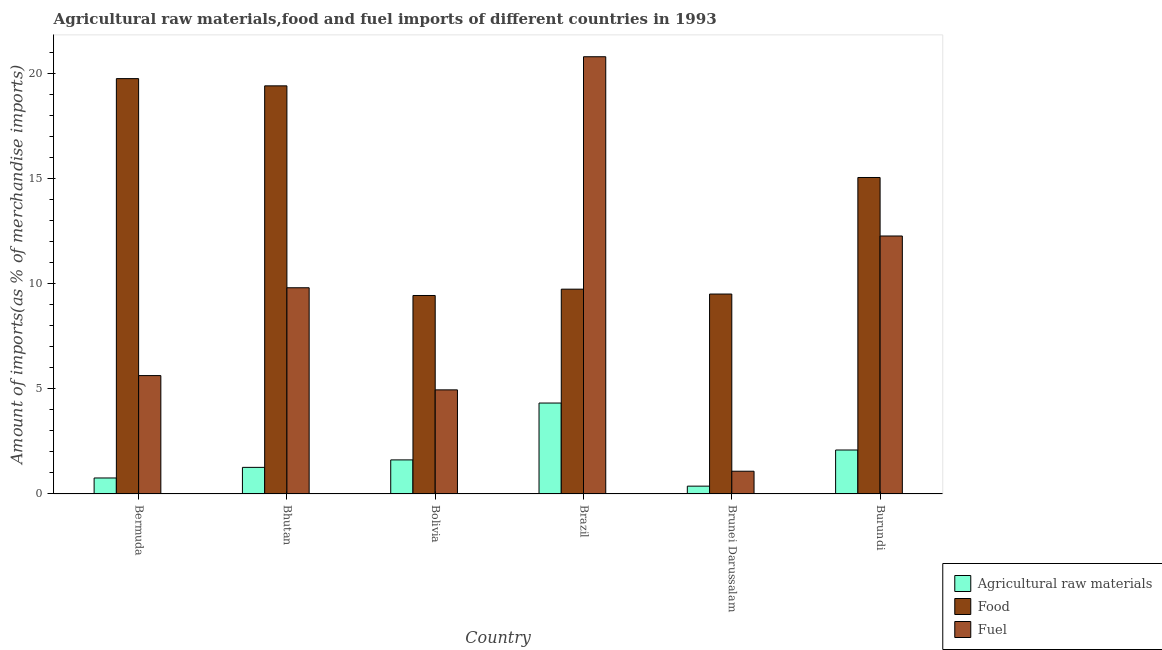How many different coloured bars are there?
Ensure brevity in your answer.  3. Are the number of bars per tick equal to the number of legend labels?
Ensure brevity in your answer.  Yes. What is the label of the 6th group of bars from the left?
Provide a short and direct response. Burundi. In how many cases, is the number of bars for a given country not equal to the number of legend labels?
Keep it short and to the point. 0. What is the percentage of food imports in Burundi?
Ensure brevity in your answer.  15.04. Across all countries, what is the maximum percentage of food imports?
Your answer should be compact. 19.74. Across all countries, what is the minimum percentage of fuel imports?
Your answer should be very brief. 1.08. In which country was the percentage of food imports maximum?
Offer a very short reply. Bermuda. In which country was the percentage of raw materials imports minimum?
Your answer should be compact. Brunei Darussalam. What is the total percentage of raw materials imports in the graph?
Offer a terse response. 10.42. What is the difference between the percentage of food imports in Bhutan and that in Brunei Darussalam?
Your answer should be compact. 9.89. What is the difference between the percentage of food imports in Burundi and the percentage of fuel imports in Brazil?
Provide a succinct answer. -5.74. What is the average percentage of food imports per country?
Give a very brief answer. 13.81. What is the difference between the percentage of fuel imports and percentage of food imports in Bermuda?
Make the answer very short. -14.11. In how many countries, is the percentage of food imports greater than 16 %?
Offer a very short reply. 2. What is the ratio of the percentage of food imports in Bolivia to that in Brunei Darussalam?
Keep it short and to the point. 0.99. Is the difference between the percentage of raw materials imports in Bermuda and Brunei Darussalam greater than the difference between the percentage of fuel imports in Bermuda and Brunei Darussalam?
Give a very brief answer. No. What is the difference between the highest and the second highest percentage of fuel imports?
Offer a very short reply. 8.52. What is the difference between the highest and the lowest percentage of food imports?
Your response must be concise. 10.31. In how many countries, is the percentage of fuel imports greater than the average percentage of fuel imports taken over all countries?
Your answer should be compact. 3. Is the sum of the percentage of food imports in Bhutan and Brunei Darussalam greater than the maximum percentage of raw materials imports across all countries?
Offer a terse response. Yes. What does the 2nd bar from the left in Bhutan represents?
Your answer should be compact. Food. What does the 2nd bar from the right in Bermuda represents?
Your answer should be compact. Food. Are all the bars in the graph horizontal?
Offer a very short reply. No. What is the difference between two consecutive major ticks on the Y-axis?
Your response must be concise. 5. Are the values on the major ticks of Y-axis written in scientific E-notation?
Provide a short and direct response. No. Does the graph contain grids?
Your response must be concise. No. How many legend labels are there?
Keep it short and to the point. 3. What is the title of the graph?
Offer a terse response. Agricultural raw materials,food and fuel imports of different countries in 1993. What is the label or title of the Y-axis?
Provide a short and direct response. Amount of imports(as % of merchandise imports). What is the Amount of imports(as % of merchandise imports) of Agricultural raw materials in Bermuda?
Keep it short and to the point. 0.76. What is the Amount of imports(as % of merchandise imports) of Food in Bermuda?
Your answer should be very brief. 19.74. What is the Amount of imports(as % of merchandise imports) in Fuel in Bermuda?
Make the answer very short. 5.63. What is the Amount of imports(as % of merchandise imports) in Agricultural raw materials in Bhutan?
Your answer should be very brief. 1.26. What is the Amount of imports(as % of merchandise imports) of Food in Bhutan?
Ensure brevity in your answer.  19.39. What is the Amount of imports(as % of merchandise imports) in Fuel in Bhutan?
Offer a very short reply. 9.8. What is the Amount of imports(as % of merchandise imports) in Agricultural raw materials in Bolivia?
Provide a succinct answer. 1.62. What is the Amount of imports(as % of merchandise imports) of Food in Bolivia?
Offer a terse response. 9.43. What is the Amount of imports(as % of merchandise imports) of Fuel in Bolivia?
Provide a short and direct response. 4.95. What is the Amount of imports(as % of merchandise imports) in Agricultural raw materials in Brazil?
Offer a terse response. 4.32. What is the Amount of imports(as % of merchandise imports) of Food in Brazil?
Provide a succinct answer. 9.73. What is the Amount of imports(as % of merchandise imports) in Fuel in Brazil?
Your response must be concise. 20.78. What is the Amount of imports(as % of merchandise imports) in Agricultural raw materials in Brunei Darussalam?
Your answer should be compact. 0.37. What is the Amount of imports(as % of merchandise imports) in Food in Brunei Darussalam?
Ensure brevity in your answer.  9.5. What is the Amount of imports(as % of merchandise imports) in Fuel in Brunei Darussalam?
Offer a terse response. 1.08. What is the Amount of imports(as % of merchandise imports) in Agricultural raw materials in Burundi?
Offer a terse response. 2.09. What is the Amount of imports(as % of merchandise imports) of Food in Burundi?
Keep it short and to the point. 15.04. What is the Amount of imports(as % of merchandise imports) in Fuel in Burundi?
Make the answer very short. 12.26. Across all countries, what is the maximum Amount of imports(as % of merchandise imports) in Agricultural raw materials?
Your answer should be very brief. 4.32. Across all countries, what is the maximum Amount of imports(as % of merchandise imports) in Food?
Provide a succinct answer. 19.74. Across all countries, what is the maximum Amount of imports(as % of merchandise imports) of Fuel?
Your response must be concise. 20.78. Across all countries, what is the minimum Amount of imports(as % of merchandise imports) in Agricultural raw materials?
Your answer should be compact. 0.37. Across all countries, what is the minimum Amount of imports(as % of merchandise imports) of Food?
Your answer should be very brief. 9.43. Across all countries, what is the minimum Amount of imports(as % of merchandise imports) of Fuel?
Ensure brevity in your answer.  1.08. What is the total Amount of imports(as % of merchandise imports) of Agricultural raw materials in the graph?
Provide a short and direct response. 10.42. What is the total Amount of imports(as % of merchandise imports) in Food in the graph?
Ensure brevity in your answer.  82.83. What is the total Amount of imports(as % of merchandise imports) in Fuel in the graph?
Offer a very short reply. 54.49. What is the difference between the Amount of imports(as % of merchandise imports) of Agricultural raw materials in Bermuda and that in Bhutan?
Your response must be concise. -0.5. What is the difference between the Amount of imports(as % of merchandise imports) of Food in Bermuda and that in Bhutan?
Provide a succinct answer. 0.34. What is the difference between the Amount of imports(as % of merchandise imports) in Fuel in Bermuda and that in Bhutan?
Provide a short and direct response. -4.17. What is the difference between the Amount of imports(as % of merchandise imports) in Agricultural raw materials in Bermuda and that in Bolivia?
Keep it short and to the point. -0.86. What is the difference between the Amount of imports(as % of merchandise imports) in Food in Bermuda and that in Bolivia?
Your answer should be very brief. 10.31. What is the difference between the Amount of imports(as % of merchandise imports) of Fuel in Bermuda and that in Bolivia?
Make the answer very short. 0.68. What is the difference between the Amount of imports(as % of merchandise imports) in Agricultural raw materials in Bermuda and that in Brazil?
Offer a terse response. -3.56. What is the difference between the Amount of imports(as % of merchandise imports) in Food in Bermuda and that in Brazil?
Offer a terse response. 10.01. What is the difference between the Amount of imports(as % of merchandise imports) of Fuel in Bermuda and that in Brazil?
Your answer should be very brief. -15.15. What is the difference between the Amount of imports(as % of merchandise imports) in Agricultural raw materials in Bermuda and that in Brunei Darussalam?
Your response must be concise. 0.39. What is the difference between the Amount of imports(as % of merchandise imports) in Food in Bermuda and that in Brunei Darussalam?
Provide a short and direct response. 10.24. What is the difference between the Amount of imports(as % of merchandise imports) in Fuel in Bermuda and that in Brunei Darussalam?
Your answer should be compact. 4.55. What is the difference between the Amount of imports(as % of merchandise imports) of Agricultural raw materials in Bermuda and that in Burundi?
Offer a very short reply. -1.33. What is the difference between the Amount of imports(as % of merchandise imports) of Food in Bermuda and that in Burundi?
Your response must be concise. 4.7. What is the difference between the Amount of imports(as % of merchandise imports) in Fuel in Bermuda and that in Burundi?
Your response must be concise. -6.63. What is the difference between the Amount of imports(as % of merchandise imports) of Agricultural raw materials in Bhutan and that in Bolivia?
Ensure brevity in your answer.  -0.35. What is the difference between the Amount of imports(as % of merchandise imports) in Food in Bhutan and that in Bolivia?
Offer a terse response. 9.96. What is the difference between the Amount of imports(as % of merchandise imports) in Fuel in Bhutan and that in Bolivia?
Your response must be concise. 4.85. What is the difference between the Amount of imports(as % of merchandise imports) of Agricultural raw materials in Bhutan and that in Brazil?
Your answer should be compact. -3.06. What is the difference between the Amount of imports(as % of merchandise imports) in Food in Bhutan and that in Brazil?
Make the answer very short. 9.66. What is the difference between the Amount of imports(as % of merchandise imports) in Fuel in Bhutan and that in Brazil?
Make the answer very short. -10.98. What is the difference between the Amount of imports(as % of merchandise imports) in Agricultural raw materials in Bhutan and that in Brunei Darussalam?
Offer a terse response. 0.89. What is the difference between the Amount of imports(as % of merchandise imports) in Food in Bhutan and that in Brunei Darussalam?
Offer a very short reply. 9.89. What is the difference between the Amount of imports(as % of merchandise imports) in Fuel in Bhutan and that in Brunei Darussalam?
Your answer should be very brief. 8.72. What is the difference between the Amount of imports(as % of merchandise imports) in Agricultural raw materials in Bhutan and that in Burundi?
Offer a very short reply. -0.82. What is the difference between the Amount of imports(as % of merchandise imports) in Food in Bhutan and that in Burundi?
Provide a short and direct response. 4.35. What is the difference between the Amount of imports(as % of merchandise imports) of Fuel in Bhutan and that in Burundi?
Give a very brief answer. -2.46. What is the difference between the Amount of imports(as % of merchandise imports) in Agricultural raw materials in Bolivia and that in Brazil?
Provide a succinct answer. -2.7. What is the difference between the Amount of imports(as % of merchandise imports) of Food in Bolivia and that in Brazil?
Offer a very short reply. -0.3. What is the difference between the Amount of imports(as % of merchandise imports) of Fuel in Bolivia and that in Brazil?
Make the answer very short. -15.83. What is the difference between the Amount of imports(as % of merchandise imports) of Agricultural raw materials in Bolivia and that in Brunei Darussalam?
Make the answer very short. 1.25. What is the difference between the Amount of imports(as % of merchandise imports) of Food in Bolivia and that in Brunei Darussalam?
Offer a terse response. -0.07. What is the difference between the Amount of imports(as % of merchandise imports) in Fuel in Bolivia and that in Brunei Darussalam?
Your answer should be very brief. 3.87. What is the difference between the Amount of imports(as % of merchandise imports) in Agricultural raw materials in Bolivia and that in Burundi?
Provide a short and direct response. -0.47. What is the difference between the Amount of imports(as % of merchandise imports) of Food in Bolivia and that in Burundi?
Keep it short and to the point. -5.61. What is the difference between the Amount of imports(as % of merchandise imports) of Fuel in Bolivia and that in Burundi?
Your answer should be compact. -7.31. What is the difference between the Amount of imports(as % of merchandise imports) in Agricultural raw materials in Brazil and that in Brunei Darussalam?
Ensure brevity in your answer.  3.95. What is the difference between the Amount of imports(as % of merchandise imports) in Food in Brazil and that in Brunei Darussalam?
Your answer should be compact. 0.23. What is the difference between the Amount of imports(as % of merchandise imports) in Fuel in Brazil and that in Brunei Darussalam?
Provide a short and direct response. 19.7. What is the difference between the Amount of imports(as % of merchandise imports) in Agricultural raw materials in Brazil and that in Burundi?
Offer a very short reply. 2.23. What is the difference between the Amount of imports(as % of merchandise imports) of Food in Brazil and that in Burundi?
Your answer should be compact. -5.31. What is the difference between the Amount of imports(as % of merchandise imports) of Fuel in Brazil and that in Burundi?
Ensure brevity in your answer.  8.52. What is the difference between the Amount of imports(as % of merchandise imports) in Agricultural raw materials in Brunei Darussalam and that in Burundi?
Make the answer very short. -1.72. What is the difference between the Amount of imports(as % of merchandise imports) in Food in Brunei Darussalam and that in Burundi?
Offer a terse response. -5.54. What is the difference between the Amount of imports(as % of merchandise imports) in Fuel in Brunei Darussalam and that in Burundi?
Give a very brief answer. -11.18. What is the difference between the Amount of imports(as % of merchandise imports) of Agricultural raw materials in Bermuda and the Amount of imports(as % of merchandise imports) of Food in Bhutan?
Give a very brief answer. -18.63. What is the difference between the Amount of imports(as % of merchandise imports) of Agricultural raw materials in Bermuda and the Amount of imports(as % of merchandise imports) of Fuel in Bhutan?
Offer a terse response. -9.04. What is the difference between the Amount of imports(as % of merchandise imports) of Food in Bermuda and the Amount of imports(as % of merchandise imports) of Fuel in Bhutan?
Your response must be concise. 9.94. What is the difference between the Amount of imports(as % of merchandise imports) in Agricultural raw materials in Bermuda and the Amount of imports(as % of merchandise imports) in Food in Bolivia?
Keep it short and to the point. -8.67. What is the difference between the Amount of imports(as % of merchandise imports) of Agricultural raw materials in Bermuda and the Amount of imports(as % of merchandise imports) of Fuel in Bolivia?
Your answer should be compact. -4.19. What is the difference between the Amount of imports(as % of merchandise imports) of Food in Bermuda and the Amount of imports(as % of merchandise imports) of Fuel in Bolivia?
Offer a very short reply. 14.79. What is the difference between the Amount of imports(as % of merchandise imports) in Agricultural raw materials in Bermuda and the Amount of imports(as % of merchandise imports) in Food in Brazil?
Your answer should be compact. -8.97. What is the difference between the Amount of imports(as % of merchandise imports) in Agricultural raw materials in Bermuda and the Amount of imports(as % of merchandise imports) in Fuel in Brazil?
Offer a terse response. -20.02. What is the difference between the Amount of imports(as % of merchandise imports) of Food in Bermuda and the Amount of imports(as % of merchandise imports) of Fuel in Brazil?
Provide a succinct answer. -1.04. What is the difference between the Amount of imports(as % of merchandise imports) in Agricultural raw materials in Bermuda and the Amount of imports(as % of merchandise imports) in Food in Brunei Darussalam?
Offer a very short reply. -8.74. What is the difference between the Amount of imports(as % of merchandise imports) in Agricultural raw materials in Bermuda and the Amount of imports(as % of merchandise imports) in Fuel in Brunei Darussalam?
Your answer should be very brief. -0.32. What is the difference between the Amount of imports(as % of merchandise imports) in Food in Bermuda and the Amount of imports(as % of merchandise imports) in Fuel in Brunei Darussalam?
Give a very brief answer. 18.66. What is the difference between the Amount of imports(as % of merchandise imports) in Agricultural raw materials in Bermuda and the Amount of imports(as % of merchandise imports) in Food in Burundi?
Your answer should be very brief. -14.28. What is the difference between the Amount of imports(as % of merchandise imports) of Agricultural raw materials in Bermuda and the Amount of imports(as % of merchandise imports) of Fuel in Burundi?
Ensure brevity in your answer.  -11.5. What is the difference between the Amount of imports(as % of merchandise imports) in Food in Bermuda and the Amount of imports(as % of merchandise imports) in Fuel in Burundi?
Make the answer very short. 7.48. What is the difference between the Amount of imports(as % of merchandise imports) in Agricultural raw materials in Bhutan and the Amount of imports(as % of merchandise imports) in Food in Bolivia?
Your response must be concise. -8.17. What is the difference between the Amount of imports(as % of merchandise imports) of Agricultural raw materials in Bhutan and the Amount of imports(as % of merchandise imports) of Fuel in Bolivia?
Ensure brevity in your answer.  -3.68. What is the difference between the Amount of imports(as % of merchandise imports) of Food in Bhutan and the Amount of imports(as % of merchandise imports) of Fuel in Bolivia?
Give a very brief answer. 14.45. What is the difference between the Amount of imports(as % of merchandise imports) in Agricultural raw materials in Bhutan and the Amount of imports(as % of merchandise imports) in Food in Brazil?
Make the answer very short. -8.47. What is the difference between the Amount of imports(as % of merchandise imports) in Agricultural raw materials in Bhutan and the Amount of imports(as % of merchandise imports) in Fuel in Brazil?
Give a very brief answer. -19.51. What is the difference between the Amount of imports(as % of merchandise imports) in Food in Bhutan and the Amount of imports(as % of merchandise imports) in Fuel in Brazil?
Provide a succinct answer. -1.38. What is the difference between the Amount of imports(as % of merchandise imports) of Agricultural raw materials in Bhutan and the Amount of imports(as % of merchandise imports) of Food in Brunei Darussalam?
Your answer should be very brief. -8.24. What is the difference between the Amount of imports(as % of merchandise imports) of Agricultural raw materials in Bhutan and the Amount of imports(as % of merchandise imports) of Fuel in Brunei Darussalam?
Keep it short and to the point. 0.18. What is the difference between the Amount of imports(as % of merchandise imports) in Food in Bhutan and the Amount of imports(as % of merchandise imports) in Fuel in Brunei Darussalam?
Make the answer very short. 18.31. What is the difference between the Amount of imports(as % of merchandise imports) of Agricultural raw materials in Bhutan and the Amount of imports(as % of merchandise imports) of Food in Burundi?
Give a very brief answer. -13.77. What is the difference between the Amount of imports(as % of merchandise imports) in Agricultural raw materials in Bhutan and the Amount of imports(as % of merchandise imports) in Fuel in Burundi?
Provide a short and direct response. -10.99. What is the difference between the Amount of imports(as % of merchandise imports) in Food in Bhutan and the Amount of imports(as % of merchandise imports) in Fuel in Burundi?
Provide a short and direct response. 7.13. What is the difference between the Amount of imports(as % of merchandise imports) in Agricultural raw materials in Bolivia and the Amount of imports(as % of merchandise imports) in Food in Brazil?
Provide a succinct answer. -8.11. What is the difference between the Amount of imports(as % of merchandise imports) of Agricultural raw materials in Bolivia and the Amount of imports(as % of merchandise imports) of Fuel in Brazil?
Offer a very short reply. -19.16. What is the difference between the Amount of imports(as % of merchandise imports) in Food in Bolivia and the Amount of imports(as % of merchandise imports) in Fuel in Brazil?
Provide a short and direct response. -11.35. What is the difference between the Amount of imports(as % of merchandise imports) of Agricultural raw materials in Bolivia and the Amount of imports(as % of merchandise imports) of Food in Brunei Darussalam?
Provide a succinct answer. -7.88. What is the difference between the Amount of imports(as % of merchandise imports) in Agricultural raw materials in Bolivia and the Amount of imports(as % of merchandise imports) in Fuel in Brunei Darussalam?
Your answer should be very brief. 0.54. What is the difference between the Amount of imports(as % of merchandise imports) in Food in Bolivia and the Amount of imports(as % of merchandise imports) in Fuel in Brunei Darussalam?
Your answer should be very brief. 8.35. What is the difference between the Amount of imports(as % of merchandise imports) of Agricultural raw materials in Bolivia and the Amount of imports(as % of merchandise imports) of Food in Burundi?
Provide a short and direct response. -13.42. What is the difference between the Amount of imports(as % of merchandise imports) in Agricultural raw materials in Bolivia and the Amount of imports(as % of merchandise imports) in Fuel in Burundi?
Ensure brevity in your answer.  -10.64. What is the difference between the Amount of imports(as % of merchandise imports) in Food in Bolivia and the Amount of imports(as % of merchandise imports) in Fuel in Burundi?
Offer a terse response. -2.83. What is the difference between the Amount of imports(as % of merchandise imports) in Agricultural raw materials in Brazil and the Amount of imports(as % of merchandise imports) in Food in Brunei Darussalam?
Provide a succinct answer. -5.18. What is the difference between the Amount of imports(as % of merchandise imports) of Agricultural raw materials in Brazil and the Amount of imports(as % of merchandise imports) of Fuel in Brunei Darussalam?
Your answer should be compact. 3.24. What is the difference between the Amount of imports(as % of merchandise imports) of Food in Brazil and the Amount of imports(as % of merchandise imports) of Fuel in Brunei Darussalam?
Offer a terse response. 8.65. What is the difference between the Amount of imports(as % of merchandise imports) of Agricultural raw materials in Brazil and the Amount of imports(as % of merchandise imports) of Food in Burundi?
Make the answer very short. -10.72. What is the difference between the Amount of imports(as % of merchandise imports) of Agricultural raw materials in Brazil and the Amount of imports(as % of merchandise imports) of Fuel in Burundi?
Provide a short and direct response. -7.94. What is the difference between the Amount of imports(as % of merchandise imports) in Food in Brazil and the Amount of imports(as % of merchandise imports) in Fuel in Burundi?
Give a very brief answer. -2.53. What is the difference between the Amount of imports(as % of merchandise imports) in Agricultural raw materials in Brunei Darussalam and the Amount of imports(as % of merchandise imports) in Food in Burundi?
Keep it short and to the point. -14.67. What is the difference between the Amount of imports(as % of merchandise imports) in Agricultural raw materials in Brunei Darussalam and the Amount of imports(as % of merchandise imports) in Fuel in Burundi?
Offer a very short reply. -11.89. What is the difference between the Amount of imports(as % of merchandise imports) in Food in Brunei Darussalam and the Amount of imports(as % of merchandise imports) in Fuel in Burundi?
Provide a short and direct response. -2.76. What is the average Amount of imports(as % of merchandise imports) in Agricultural raw materials per country?
Your answer should be very brief. 1.74. What is the average Amount of imports(as % of merchandise imports) of Food per country?
Ensure brevity in your answer.  13.81. What is the average Amount of imports(as % of merchandise imports) in Fuel per country?
Ensure brevity in your answer.  9.08. What is the difference between the Amount of imports(as % of merchandise imports) in Agricultural raw materials and Amount of imports(as % of merchandise imports) in Food in Bermuda?
Give a very brief answer. -18.98. What is the difference between the Amount of imports(as % of merchandise imports) of Agricultural raw materials and Amount of imports(as % of merchandise imports) of Fuel in Bermuda?
Give a very brief answer. -4.87. What is the difference between the Amount of imports(as % of merchandise imports) of Food and Amount of imports(as % of merchandise imports) of Fuel in Bermuda?
Keep it short and to the point. 14.11. What is the difference between the Amount of imports(as % of merchandise imports) in Agricultural raw materials and Amount of imports(as % of merchandise imports) in Food in Bhutan?
Your answer should be very brief. -18.13. What is the difference between the Amount of imports(as % of merchandise imports) in Agricultural raw materials and Amount of imports(as % of merchandise imports) in Fuel in Bhutan?
Provide a short and direct response. -8.53. What is the difference between the Amount of imports(as % of merchandise imports) of Food and Amount of imports(as % of merchandise imports) of Fuel in Bhutan?
Provide a succinct answer. 9.59. What is the difference between the Amount of imports(as % of merchandise imports) in Agricultural raw materials and Amount of imports(as % of merchandise imports) in Food in Bolivia?
Provide a short and direct response. -7.81. What is the difference between the Amount of imports(as % of merchandise imports) of Agricultural raw materials and Amount of imports(as % of merchandise imports) of Fuel in Bolivia?
Keep it short and to the point. -3.33. What is the difference between the Amount of imports(as % of merchandise imports) in Food and Amount of imports(as % of merchandise imports) in Fuel in Bolivia?
Your answer should be very brief. 4.48. What is the difference between the Amount of imports(as % of merchandise imports) of Agricultural raw materials and Amount of imports(as % of merchandise imports) of Food in Brazil?
Your answer should be compact. -5.41. What is the difference between the Amount of imports(as % of merchandise imports) of Agricultural raw materials and Amount of imports(as % of merchandise imports) of Fuel in Brazil?
Give a very brief answer. -16.46. What is the difference between the Amount of imports(as % of merchandise imports) in Food and Amount of imports(as % of merchandise imports) in Fuel in Brazil?
Provide a short and direct response. -11.04. What is the difference between the Amount of imports(as % of merchandise imports) of Agricultural raw materials and Amount of imports(as % of merchandise imports) of Food in Brunei Darussalam?
Give a very brief answer. -9.13. What is the difference between the Amount of imports(as % of merchandise imports) in Agricultural raw materials and Amount of imports(as % of merchandise imports) in Fuel in Brunei Darussalam?
Your response must be concise. -0.71. What is the difference between the Amount of imports(as % of merchandise imports) of Food and Amount of imports(as % of merchandise imports) of Fuel in Brunei Darussalam?
Keep it short and to the point. 8.42. What is the difference between the Amount of imports(as % of merchandise imports) of Agricultural raw materials and Amount of imports(as % of merchandise imports) of Food in Burundi?
Offer a terse response. -12.95. What is the difference between the Amount of imports(as % of merchandise imports) of Agricultural raw materials and Amount of imports(as % of merchandise imports) of Fuel in Burundi?
Your answer should be compact. -10.17. What is the difference between the Amount of imports(as % of merchandise imports) of Food and Amount of imports(as % of merchandise imports) of Fuel in Burundi?
Give a very brief answer. 2.78. What is the ratio of the Amount of imports(as % of merchandise imports) of Agricultural raw materials in Bermuda to that in Bhutan?
Offer a very short reply. 0.6. What is the ratio of the Amount of imports(as % of merchandise imports) in Food in Bermuda to that in Bhutan?
Provide a succinct answer. 1.02. What is the ratio of the Amount of imports(as % of merchandise imports) of Fuel in Bermuda to that in Bhutan?
Provide a succinct answer. 0.57. What is the ratio of the Amount of imports(as % of merchandise imports) in Agricultural raw materials in Bermuda to that in Bolivia?
Ensure brevity in your answer.  0.47. What is the ratio of the Amount of imports(as % of merchandise imports) in Food in Bermuda to that in Bolivia?
Your answer should be compact. 2.09. What is the ratio of the Amount of imports(as % of merchandise imports) in Fuel in Bermuda to that in Bolivia?
Offer a terse response. 1.14. What is the ratio of the Amount of imports(as % of merchandise imports) of Agricultural raw materials in Bermuda to that in Brazil?
Ensure brevity in your answer.  0.18. What is the ratio of the Amount of imports(as % of merchandise imports) of Food in Bermuda to that in Brazil?
Offer a very short reply. 2.03. What is the ratio of the Amount of imports(as % of merchandise imports) of Fuel in Bermuda to that in Brazil?
Keep it short and to the point. 0.27. What is the ratio of the Amount of imports(as % of merchandise imports) of Agricultural raw materials in Bermuda to that in Brunei Darussalam?
Provide a succinct answer. 2.04. What is the ratio of the Amount of imports(as % of merchandise imports) in Food in Bermuda to that in Brunei Darussalam?
Keep it short and to the point. 2.08. What is the ratio of the Amount of imports(as % of merchandise imports) of Fuel in Bermuda to that in Brunei Darussalam?
Your answer should be compact. 5.21. What is the ratio of the Amount of imports(as % of merchandise imports) of Agricultural raw materials in Bermuda to that in Burundi?
Give a very brief answer. 0.36. What is the ratio of the Amount of imports(as % of merchandise imports) in Food in Bermuda to that in Burundi?
Your response must be concise. 1.31. What is the ratio of the Amount of imports(as % of merchandise imports) in Fuel in Bermuda to that in Burundi?
Your answer should be very brief. 0.46. What is the ratio of the Amount of imports(as % of merchandise imports) of Agricultural raw materials in Bhutan to that in Bolivia?
Make the answer very short. 0.78. What is the ratio of the Amount of imports(as % of merchandise imports) in Food in Bhutan to that in Bolivia?
Your response must be concise. 2.06. What is the ratio of the Amount of imports(as % of merchandise imports) in Fuel in Bhutan to that in Bolivia?
Offer a very short reply. 1.98. What is the ratio of the Amount of imports(as % of merchandise imports) of Agricultural raw materials in Bhutan to that in Brazil?
Provide a short and direct response. 0.29. What is the ratio of the Amount of imports(as % of merchandise imports) of Food in Bhutan to that in Brazil?
Your response must be concise. 1.99. What is the ratio of the Amount of imports(as % of merchandise imports) in Fuel in Bhutan to that in Brazil?
Your response must be concise. 0.47. What is the ratio of the Amount of imports(as % of merchandise imports) in Agricultural raw materials in Bhutan to that in Brunei Darussalam?
Offer a terse response. 3.4. What is the ratio of the Amount of imports(as % of merchandise imports) in Food in Bhutan to that in Brunei Darussalam?
Provide a succinct answer. 2.04. What is the ratio of the Amount of imports(as % of merchandise imports) of Fuel in Bhutan to that in Brunei Darussalam?
Your answer should be compact. 9.07. What is the ratio of the Amount of imports(as % of merchandise imports) in Agricultural raw materials in Bhutan to that in Burundi?
Provide a short and direct response. 0.61. What is the ratio of the Amount of imports(as % of merchandise imports) in Food in Bhutan to that in Burundi?
Your answer should be compact. 1.29. What is the ratio of the Amount of imports(as % of merchandise imports) in Fuel in Bhutan to that in Burundi?
Your answer should be compact. 0.8. What is the ratio of the Amount of imports(as % of merchandise imports) of Agricultural raw materials in Bolivia to that in Brazil?
Give a very brief answer. 0.37. What is the ratio of the Amount of imports(as % of merchandise imports) of Food in Bolivia to that in Brazil?
Provide a short and direct response. 0.97. What is the ratio of the Amount of imports(as % of merchandise imports) of Fuel in Bolivia to that in Brazil?
Offer a very short reply. 0.24. What is the ratio of the Amount of imports(as % of merchandise imports) of Agricultural raw materials in Bolivia to that in Brunei Darussalam?
Ensure brevity in your answer.  4.36. What is the ratio of the Amount of imports(as % of merchandise imports) in Food in Bolivia to that in Brunei Darussalam?
Offer a terse response. 0.99. What is the ratio of the Amount of imports(as % of merchandise imports) in Fuel in Bolivia to that in Brunei Darussalam?
Your answer should be compact. 4.58. What is the ratio of the Amount of imports(as % of merchandise imports) in Agricultural raw materials in Bolivia to that in Burundi?
Give a very brief answer. 0.77. What is the ratio of the Amount of imports(as % of merchandise imports) in Food in Bolivia to that in Burundi?
Provide a short and direct response. 0.63. What is the ratio of the Amount of imports(as % of merchandise imports) of Fuel in Bolivia to that in Burundi?
Offer a very short reply. 0.4. What is the ratio of the Amount of imports(as % of merchandise imports) in Agricultural raw materials in Brazil to that in Brunei Darussalam?
Provide a succinct answer. 11.63. What is the ratio of the Amount of imports(as % of merchandise imports) of Food in Brazil to that in Brunei Darussalam?
Keep it short and to the point. 1.02. What is the ratio of the Amount of imports(as % of merchandise imports) in Fuel in Brazil to that in Brunei Darussalam?
Provide a succinct answer. 19.23. What is the ratio of the Amount of imports(as % of merchandise imports) in Agricultural raw materials in Brazil to that in Burundi?
Provide a succinct answer. 2.07. What is the ratio of the Amount of imports(as % of merchandise imports) in Food in Brazil to that in Burundi?
Keep it short and to the point. 0.65. What is the ratio of the Amount of imports(as % of merchandise imports) in Fuel in Brazil to that in Burundi?
Give a very brief answer. 1.69. What is the ratio of the Amount of imports(as % of merchandise imports) of Agricultural raw materials in Brunei Darussalam to that in Burundi?
Your response must be concise. 0.18. What is the ratio of the Amount of imports(as % of merchandise imports) in Food in Brunei Darussalam to that in Burundi?
Provide a short and direct response. 0.63. What is the ratio of the Amount of imports(as % of merchandise imports) of Fuel in Brunei Darussalam to that in Burundi?
Make the answer very short. 0.09. What is the difference between the highest and the second highest Amount of imports(as % of merchandise imports) of Agricultural raw materials?
Your answer should be very brief. 2.23. What is the difference between the highest and the second highest Amount of imports(as % of merchandise imports) in Food?
Your answer should be compact. 0.34. What is the difference between the highest and the second highest Amount of imports(as % of merchandise imports) of Fuel?
Offer a terse response. 8.52. What is the difference between the highest and the lowest Amount of imports(as % of merchandise imports) of Agricultural raw materials?
Keep it short and to the point. 3.95. What is the difference between the highest and the lowest Amount of imports(as % of merchandise imports) in Food?
Ensure brevity in your answer.  10.31. What is the difference between the highest and the lowest Amount of imports(as % of merchandise imports) in Fuel?
Your response must be concise. 19.7. 